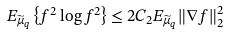Convert formula to latex. <formula><loc_0><loc_0><loc_500><loc_500>E _ { \widetilde { \mu } _ { q } } \left \{ f ^ { 2 } \log f ^ { 2 } \right \} \leq 2 C _ { 2 } E _ { \widetilde { \mu } _ { q } } \| \nabla f \| _ { 2 } ^ { 2 }</formula> 